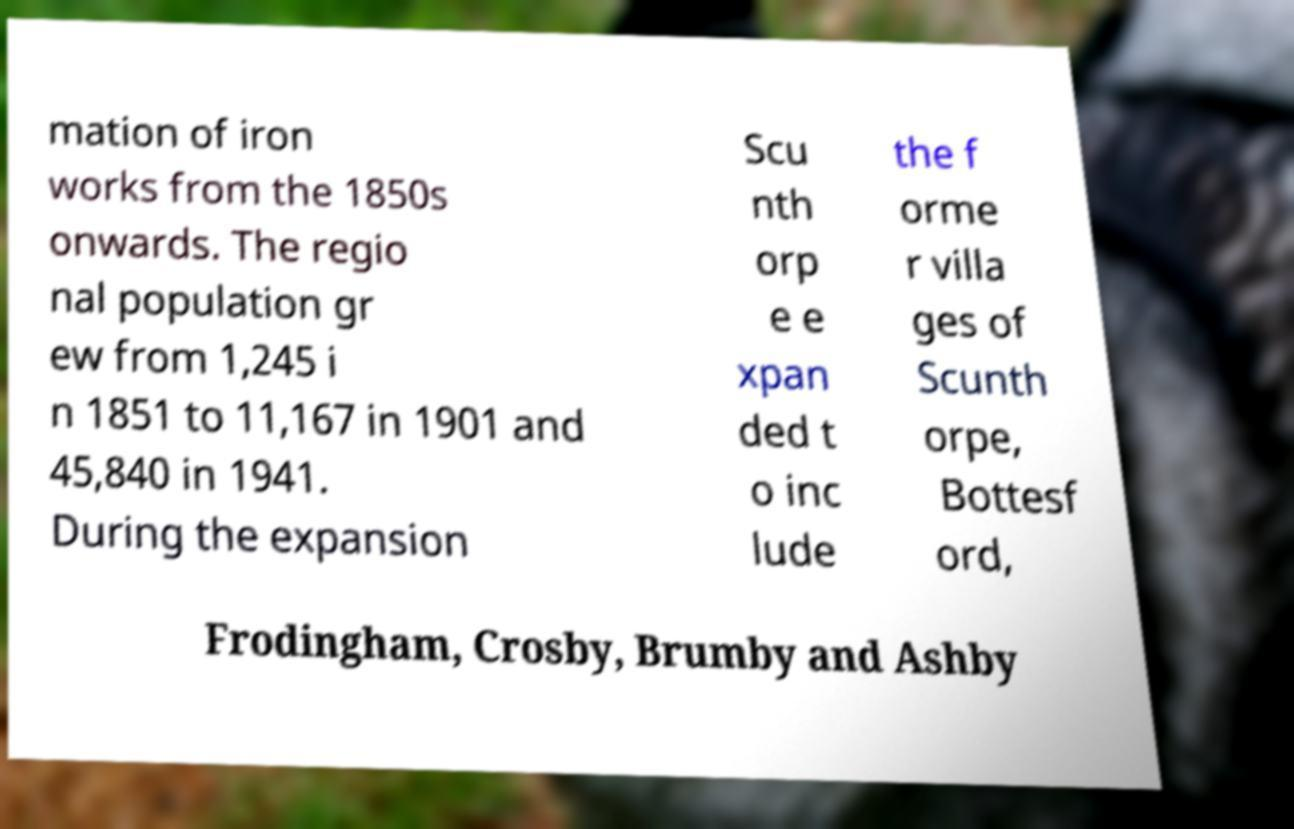Please read and relay the text visible in this image. What does it say? mation of iron works from the 1850s onwards. The regio nal population gr ew from 1,245 i n 1851 to 11,167 in 1901 and 45,840 in 1941. During the expansion Scu nth orp e e xpan ded t o inc lude the f orme r villa ges of Scunth orpe, Bottesf ord, Frodingham, Crosby, Brumby and Ashby 